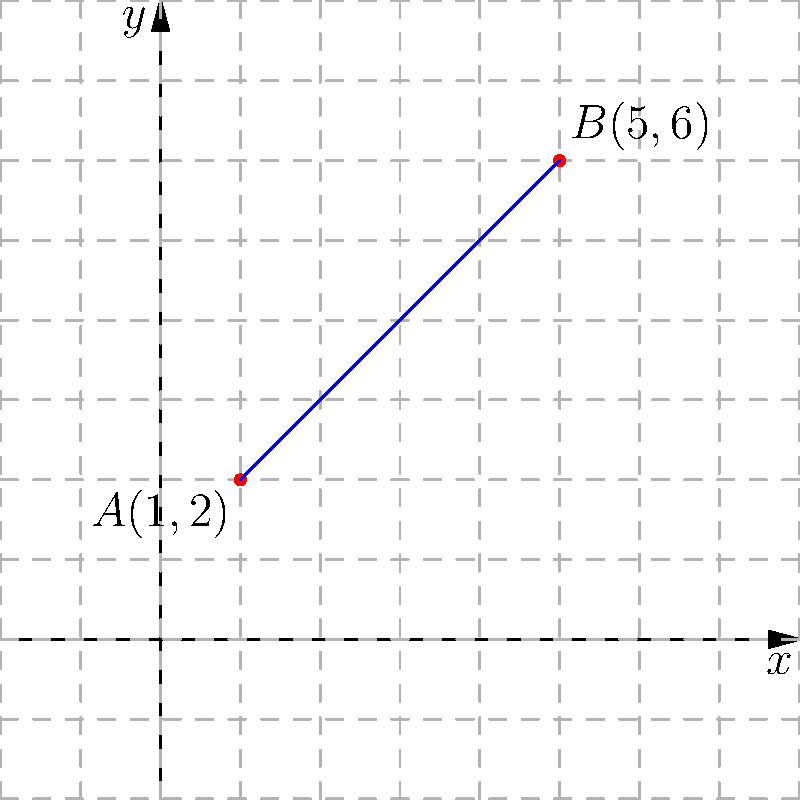Given two points $A(1,2)$ and $B(5,6)$ on a line as shown in the coordinate plane above, determine the slope of the line passing through these points. How would you guide your high school students to solve this problem systematically? To guide high school students in solving this problem systematically, we can follow these steps:

1) Recall the slope formula:
   The slope (m) of a line passing through two points $(x_1, y_1)$ and $(x_2, y_2)$ is given by:
   
   $$m = \frac{y_2 - y_1}{x_2 - x_1}$$

2) Identify the coordinates:
   Point A: $(x_1, y_1) = (1, 2)$
   Point B: $(x_2, y_2) = (5, 6)$

3) Substitute these values into the slope formula:
   
   $$m = \frac{6 - 2}{5 - 1}$$

4) Simplify the numerator and denominator:
   
   $$m = \frac{4}{4}$$

5) Perform the division:
   
   $$m = 1$$

6) Interpret the result:
   The slope of the line is 1, which means for every 1 unit increase in x, y increases by 1 unit.

7) Verify visually:
   The line in the graph indeed rises by 1 unit for every 1 unit it moves to the right, confirming our calculated slope.

By following these steps, students can systematically approach and solve slope problems, reinforcing their understanding of coordinate geometry concepts.
Answer: $m = 1$ 